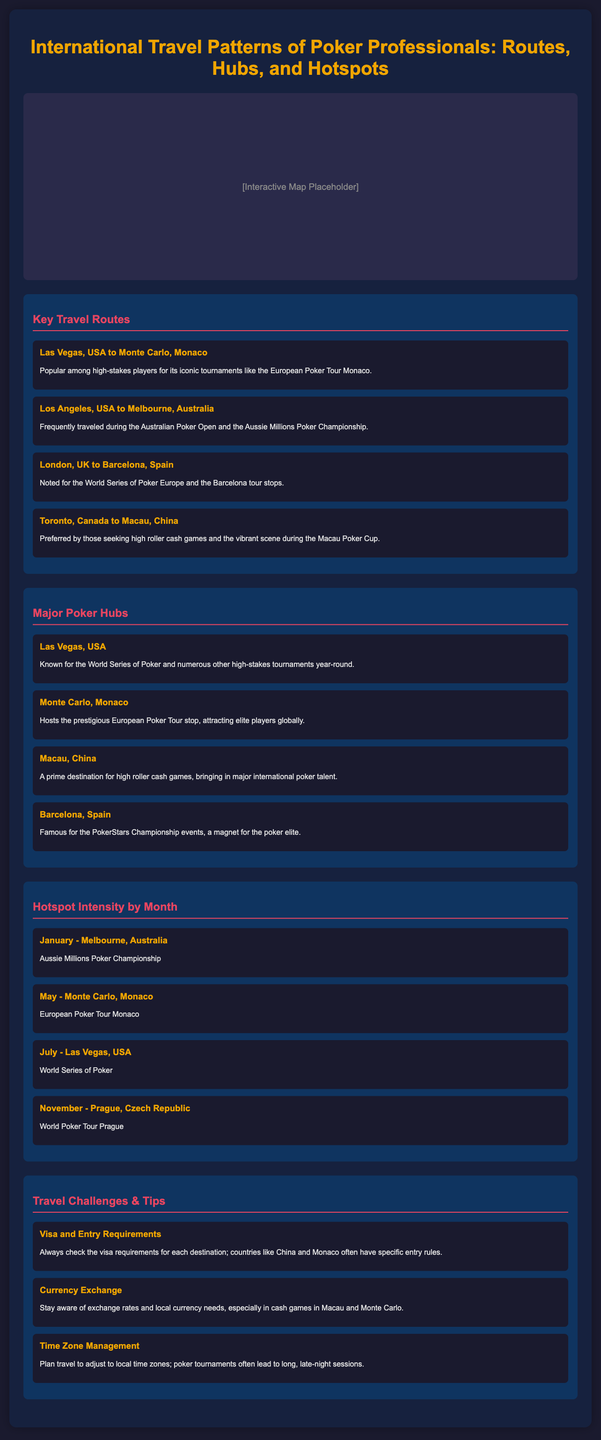What is the most popular travel route for high-stakes players? The route from Las Vegas, USA to Monte Carlo, Monaco is popular among high-stakes players for iconic tournaments.
Answer: Las Vegas, USA to Monte Carlo, Monaco Which city is known for the World Series of Poker? Las Vegas, USA hosts the World Series of Poker and numerous other high-stakes tournaments year-round.
Answer: Las Vegas, USA What month is associated with the Aussie Millions Poker Championship? January is the month during which the Aussie Millions Poker Championship takes place in Melbourne, Australia.
Answer: January What is a common travel challenge mentioned? Visa and entry requirements are a common travel challenge highlighted in the document.
Answer: Visa and entry requirements Which poker hub hosts the European Poker Tour stop? Monte Carlo, Monaco is known for hosting the prestigious European Poker Tour stop.
Answer: Monte Carlo, Monaco What currency-related advice is provided in the challenges section? The document advises to stay aware of exchange rates and local currency needs, especially in cash games.
Answer: Currency exchange Which city is featured for the World Poker Tour in November? Prague, Czech Republic is noted for hosting the World Poker Tour in November.
Answer: Prague, Czech Republic What is a recommended travel tip regarding time zones? The document suggests planning travel to adjust to local time zones, as poker tournaments often result in late-night sessions.
Answer: Time Zone Management 